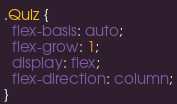Convert code to text. <code><loc_0><loc_0><loc_500><loc_500><_CSS_>.Quiz {
  flex-basis: auto;
  flex-grow: 1;
  display: flex;
  flex-direction: column;
}
</code> 